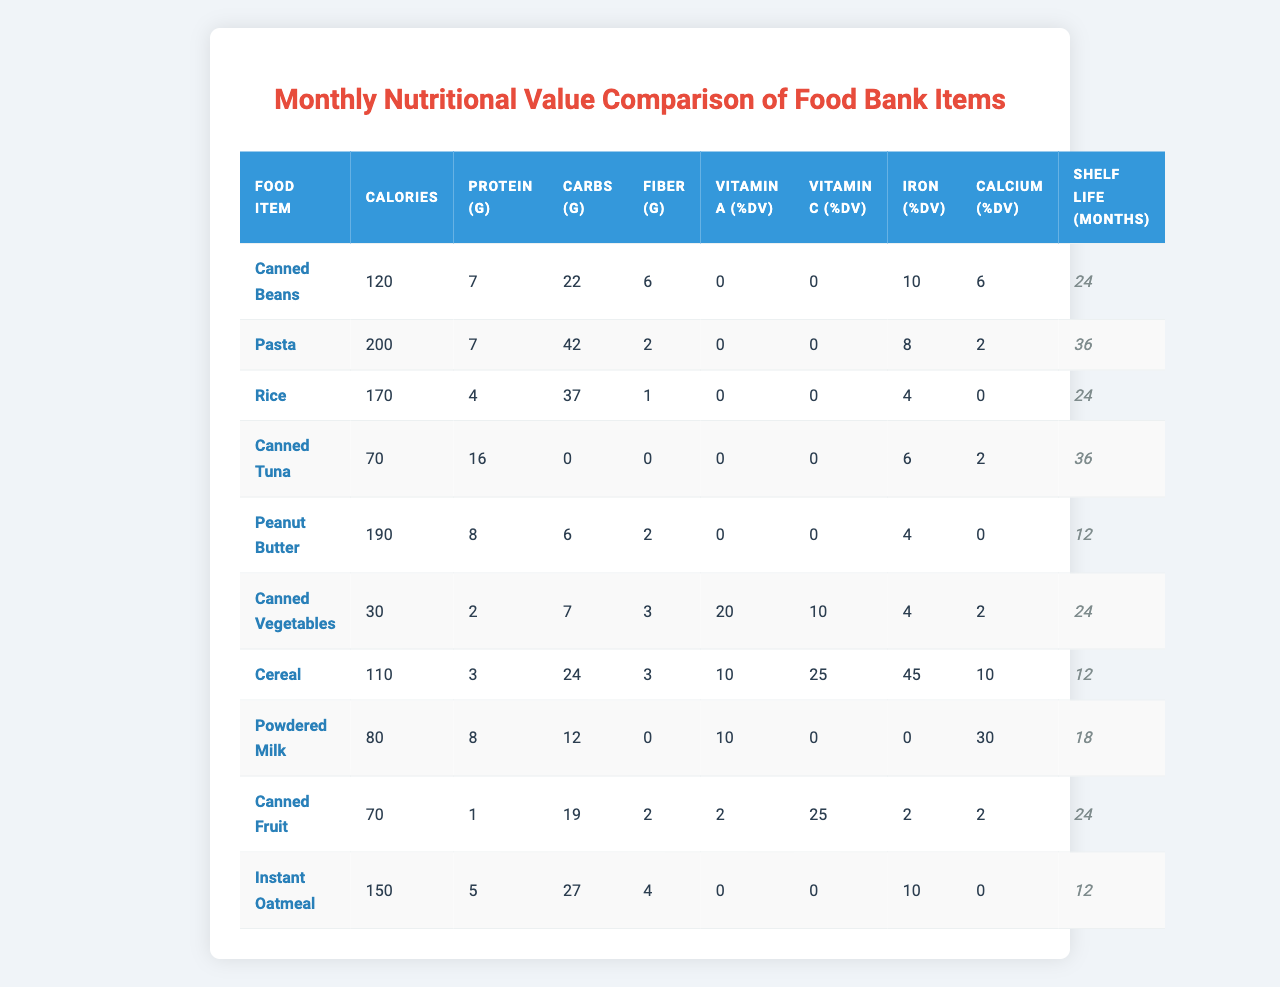What food item has the highest protein content? Looking at the "Protein (g)" column, Canned Tuna has the highest value at 16 grams per serving.
Answer: Canned Tuna What is the average amount of fiber in the food items? To find the average, add all fiber values (6 + 2 + 1 + 0 + 2 + 3 + 3 + 0 + 2 + 4 = 23) and divide by the number of food items (10), yielding an average of 23/10 = 2.3 grams of fiber.
Answer: 2.3 grams Is it true that Canned Vegetables have more calories than Instant Oatmeal? Checking the "Calories per Serving" column, Canned Vegetables have 30 calories, which is less than Instant Oatmeal's 150 calories. Thus, the statement is false.
Answer: No What is the total amount of carbohydrates for Canned Beans and Canned Tuna combined? First, find the carbohydrate values for both: Canned Beans has 22 grams, and Canned Tuna has 0 grams. Adding these gives 22 + 0 = 22 grams of carbohydrates in total.
Answer: 22 grams Which food item has the longest shelf life? From the "Shelf Life (months)" column, Pasta has the longest shelf life at 36 months.
Answer: Pasta How much vitamin C do Canned Fruit and Canned Vegetables provide together? Look at their Vitamin C values: Canned Fruit provides 25% DV, and Canned Vegetables provides 10% DV. Adding them together gives 25 + 10 = 35% DV of Vitamin C.
Answer: 35% DV Are there any food items that have zero grams of carbohydrates? Reviewing the "Carbohydrates (g)" column, it is clear that Canned Tuna has 0 grams of carbohydrates. So, there is at least one item that meets this criterion.
Answer: Yes What food items are sources of Vitamin A? Check the "Vitamin A (% DV)" column - only Canned Vegetables provides 20% DV of Vitamin A, which indicates it as a source.
Answer: Canned Vegetables What is the combined protein content of Instant Oatmeal and Peanut Butter? The protein content for Instant Oatmeal is 5 grams, and for Peanut Butter, it's 8 grams. Adding them gives 5 + 8 = 13 grams of protein combined.
Answer: 13 grams Which two food items provide the least shelf life? The shelf life values show that both Peanut Butter and Instant Oatmeal have the least at 12 months each.
Answer: Peanut Butter and Instant Oatmeal 